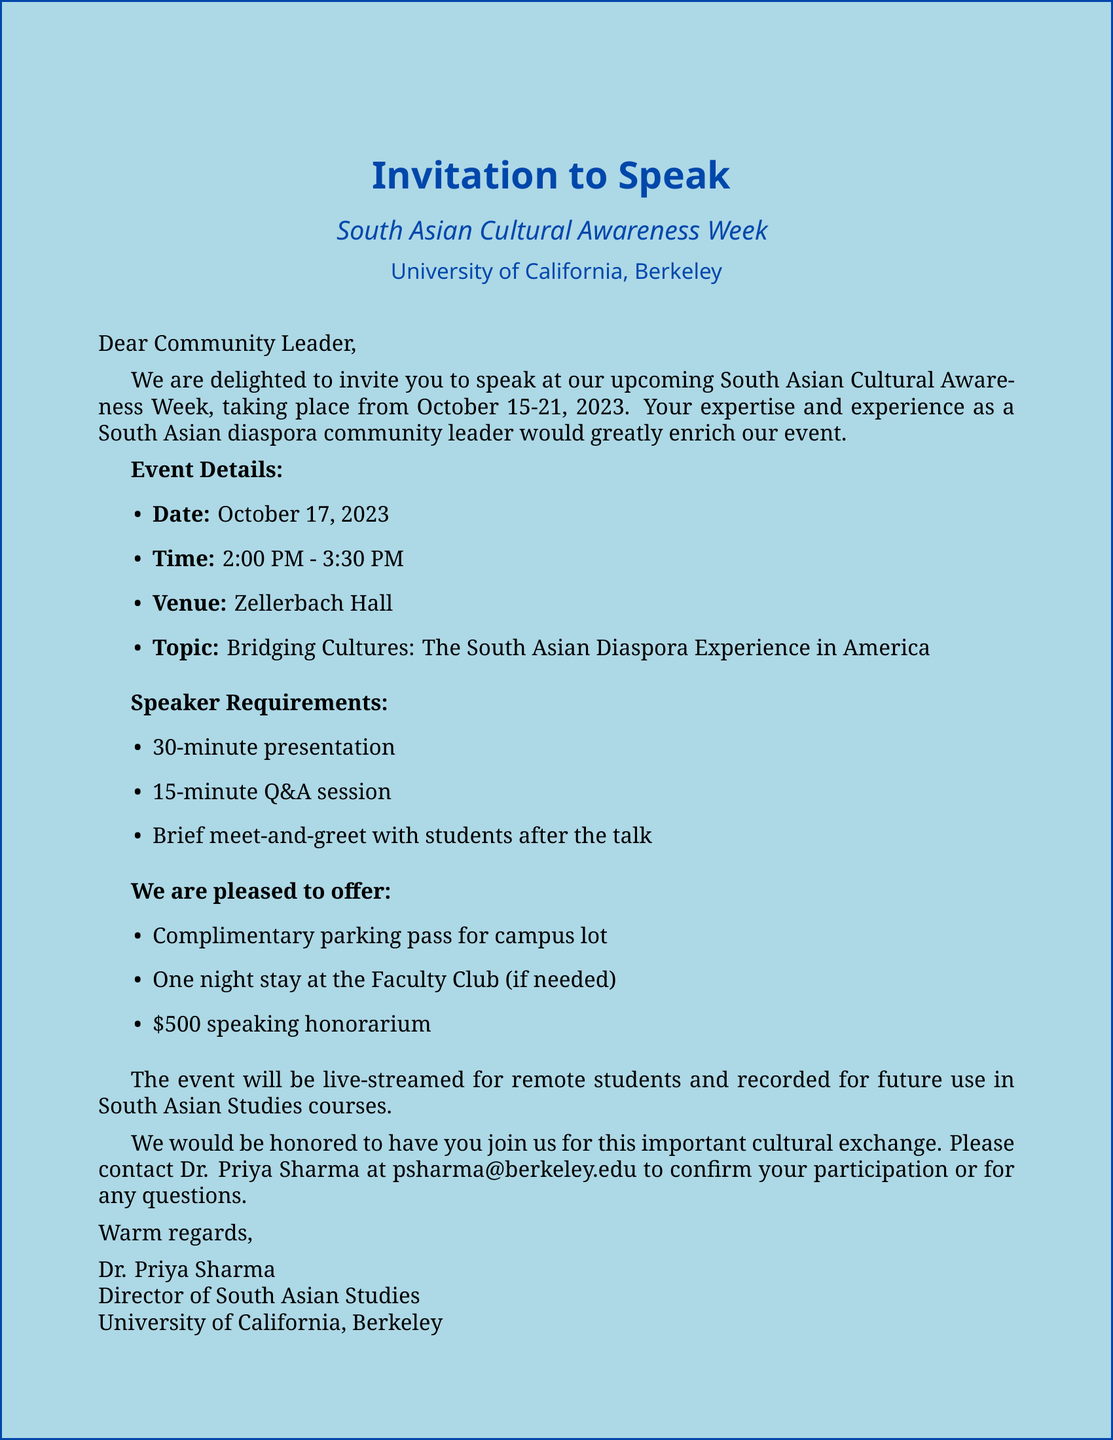What is the event name? The event name is explicitly mentioned in the document as "South Asian Cultural Awareness Week".
Answer: South Asian Cultural Awareness Week What are the dates for the event? The date range for the event is specified in the document as October 15-21, 2023.
Answer: October 15-21, 2023 Who is the event organizer? The document identifies Dr. Priya Sharma as the organizer of the event.
Answer: Dr. Priya Sharma What time is the speaking session? The document states that the speaking time is from 2:00 PM to 3:30 PM on October 17, 2023.
Answer: 2:00 PM - 3:30 PM What is the honorarium amount? The document specifies the speaking fee as $500.
Answer: $500 What will the event include? The document highlights various activities including panel discussions, cultural performances, and cuisine tasting sessions.
Answer: Panel discussions on South Asian literature and cinema, cultural performances showcasing traditional and modern art forms, South Asian cuisine tasting sessions How long is the presentation required to be? The document states that the presentation should last for 30 minutes.
Answer: 30 minutes What is provided for transportation? The document mentions that a complimentary parking pass will be provided for the campus lot.
Answer: Complimentary parking pass What is a unique feature of this event? The document notes that the event will be live-streamed and recorded for future use.
Answer: The event will be live-streamed for remote students and recorded for future use in South Asian Studies courses 